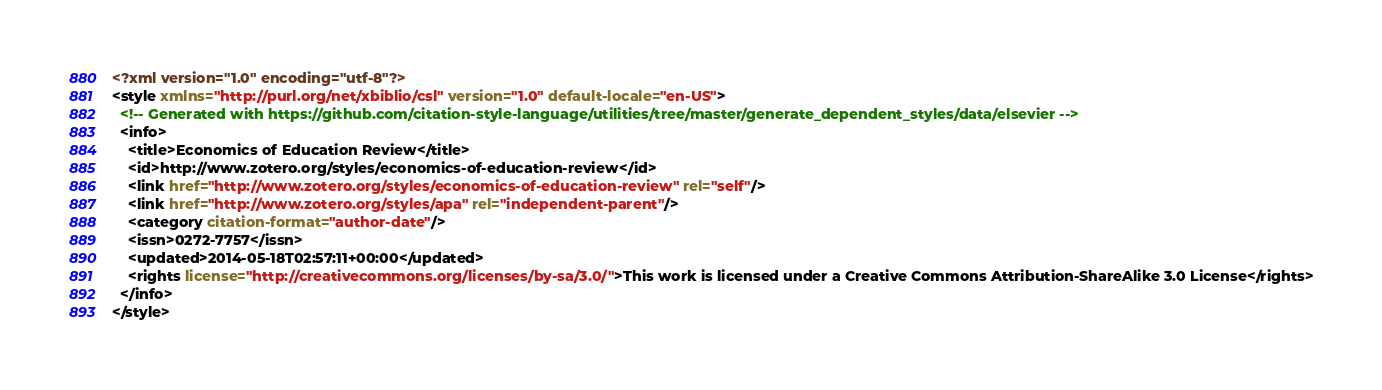<code> <loc_0><loc_0><loc_500><loc_500><_XML_><?xml version="1.0" encoding="utf-8"?>
<style xmlns="http://purl.org/net/xbiblio/csl" version="1.0" default-locale="en-US">
  <!-- Generated with https://github.com/citation-style-language/utilities/tree/master/generate_dependent_styles/data/elsevier -->
  <info>
    <title>Economics of Education Review</title>
    <id>http://www.zotero.org/styles/economics-of-education-review</id>
    <link href="http://www.zotero.org/styles/economics-of-education-review" rel="self"/>
    <link href="http://www.zotero.org/styles/apa" rel="independent-parent"/>
    <category citation-format="author-date"/>
    <issn>0272-7757</issn>
    <updated>2014-05-18T02:57:11+00:00</updated>
    <rights license="http://creativecommons.org/licenses/by-sa/3.0/">This work is licensed under a Creative Commons Attribution-ShareAlike 3.0 License</rights>
  </info>
</style>
</code> 